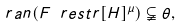<formula> <loc_0><loc_0><loc_500><loc_500>\ r a n ( F \ r e s t r [ H ] ^ { \mu } ) \subsetneqq \theta ,</formula> 